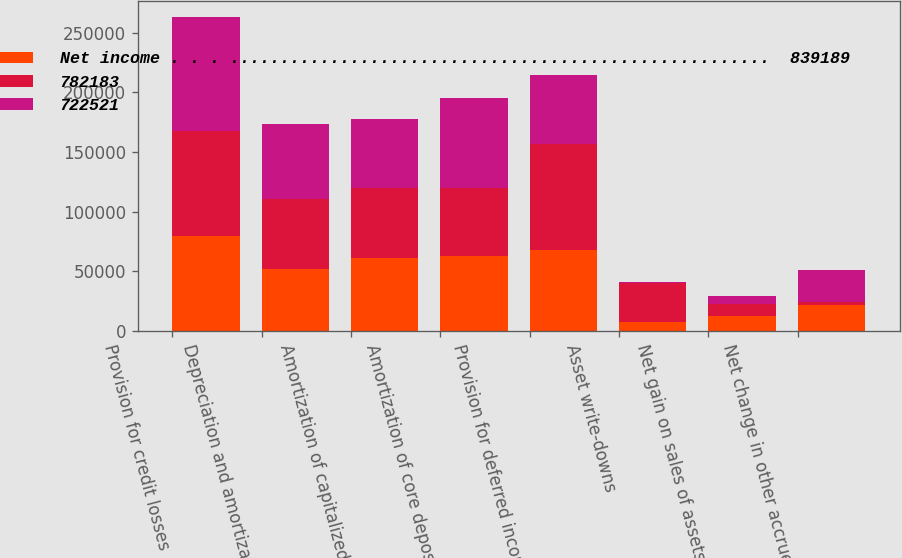Convert chart. <chart><loc_0><loc_0><loc_500><loc_500><stacked_bar_chart><ecel><fcel>Provision for credit losses<fcel>Depreciation and amortization<fcel>Amortization of capitalized<fcel>Amortization of core deposit<fcel>Provision for deferred income<fcel>Asset write-downs<fcel>Net gain on sales of assets<fcel>Net change in other accrued<nl><fcel>Net income . . . ......................................................  839189<fcel>80000<fcel>51916<fcel>61007<fcel>63008<fcel>68249<fcel>7713<fcel>12915<fcel>21493<nl><fcel>782183<fcel>88000<fcel>58477<fcel>58466<fcel>56805<fcel>88071<fcel>32765<fcel>9694<fcel>3099<nl><fcel>722521<fcel>95000<fcel>62779<fcel>57885<fcel>75410<fcel>57885<fcel>737<fcel>7127<fcel>26438<nl></chart> 